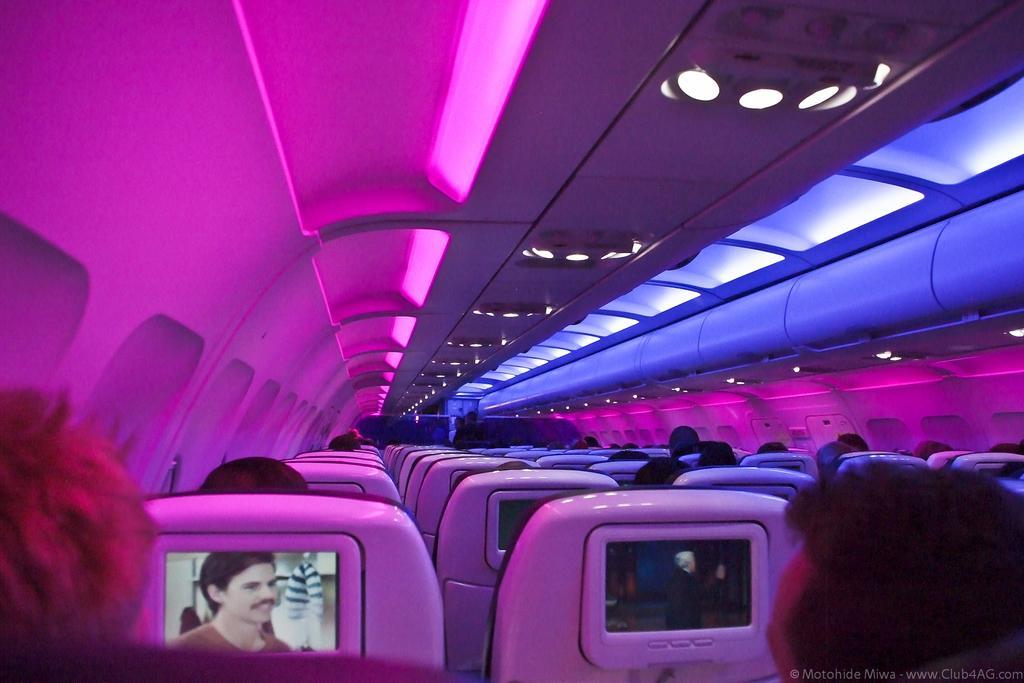Please provide a concise description of this image. In this picture we can observe an airplane in which there is a screen fixed to the back of every seat. There are some passengers in this airplane. We can observe pink and blue color lights inside the plane. 